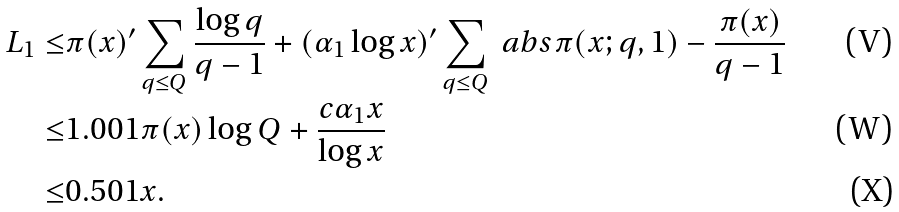<formula> <loc_0><loc_0><loc_500><loc_500>L _ { 1 } \leq & \pi ( x ) { ^ { \prime } } \sum _ { q \leq Q } \frac { \log q } { q - 1 } + ( \alpha _ { 1 } \log x ) { ^ { \prime } } \sum _ { q \leq Q } \ a b s { \pi ( x ; q , 1 ) - \frac { \pi ( x ) } { q - 1 } } \\ \leq & 1 . 0 0 1 \pi ( x ) \log Q + \frac { c \alpha _ { 1 } x } { \log x } \\ \leq & 0 . 5 0 1 x .</formula> 